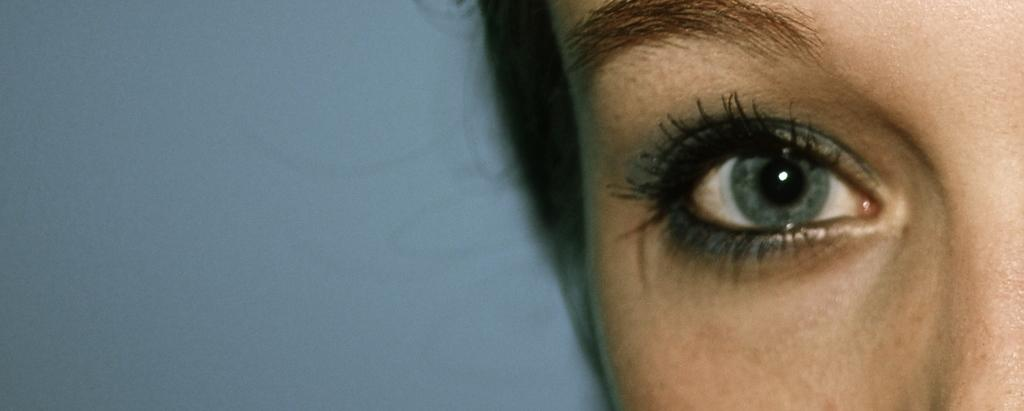What is the main subject of the picture? The main subject of the picture is an eye. What colors are present around the eye in the image? The eye has blue color above and below it. What is the color of the background in the image? The background of the image is light blue. How many pickles are visible in the image? There are no pickles present in the image; it features an eye with blue color above and below it, and a light blue background. What type of connection is established between the eye and the background in the image? There is no direct connection between the eye and the background in the image; they are separate elements in the design. 